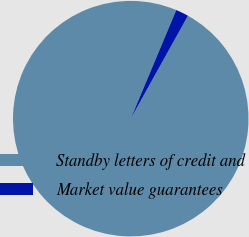<chart> <loc_0><loc_0><loc_500><loc_500><pie_chart><fcel>Standby letters of credit and<fcel>Market value guarantees<nl><fcel>98.24%<fcel>1.76%<nl></chart> 